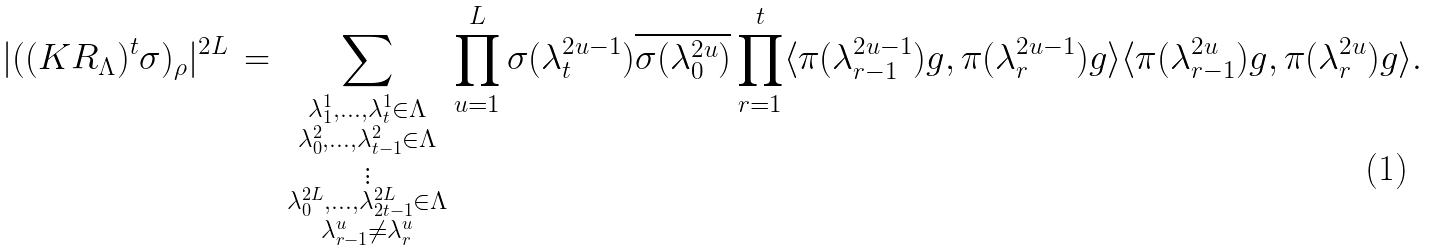Convert formula to latex. <formula><loc_0><loc_0><loc_500><loc_500>| ( ( K R _ { \Lambda } ) ^ { t } \sigma ) _ { \rho } | ^ { 2 L } \, = \, \sum _ { \substack { \lambda _ { 1 } ^ { 1 } , \hdots , \lambda _ { t } ^ { 1 } \in \Lambda \\ \lambda _ { 0 } ^ { 2 } , \hdots , \lambda _ { t - 1 } ^ { 2 } \in \Lambda \\ \vdots \\ \lambda _ { 0 } ^ { 2 L } , \hdots , \lambda _ { 2 t - 1 } ^ { 2 L } \in \Lambda \\ \lambda _ { r - 1 } ^ { u } \neq \lambda _ { r } ^ { u } } } \prod _ { u = 1 } ^ { L } \sigma ( \lambda _ { t } ^ { 2 u - 1 } ) \overline { \sigma ( \lambda _ { 0 } ^ { 2 u } ) } \prod _ { r = 1 } ^ { t } \langle \pi ( \lambda _ { r - 1 } ^ { 2 u - 1 } ) g , \pi ( \lambda _ { r } ^ { 2 u - 1 } ) g \rangle \langle \pi ( \lambda _ { r - 1 } ^ { 2 u } ) g , \pi ( \lambda _ { r } ^ { 2 u } ) g \rangle .</formula> 